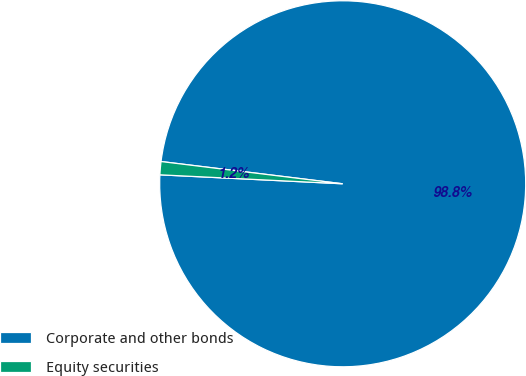Convert chart to OTSL. <chart><loc_0><loc_0><loc_500><loc_500><pie_chart><fcel>Corporate and other bonds<fcel>Equity securities<nl><fcel>98.84%<fcel>1.16%<nl></chart> 